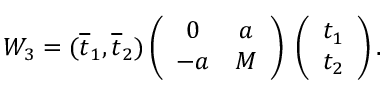Convert formula to latex. <formula><loc_0><loc_0><loc_500><loc_500>W _ { 3 } = ( \overline { t } _ { 1 } , \overline { t } _ { 2 } ) \left ( \begin{array} { c c } { 0 } & { a } \\ { - a } & { M } \end{array} \right ) \, \left ( \begin{array} { c } { { t _ { 1 } } } \\ { { t _ { 2 } } } \end{array} \right ) .</formula> 